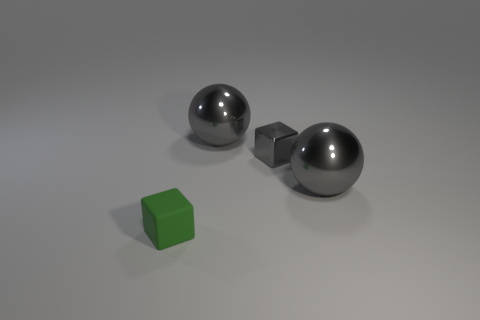Is there any other thing that is made of the same material as the small green object?
Offer a terse response. No. How many other things are the same shape as the small shiny object?
Keep it short and to the point. 1. There is a small thing behind the small matte thing; what shape is it?
Offer a terse response. Cube. The rubber block is what color?
Ensure brevity in your answer.  Green. What number of other things are the same size as the metallic cube?
Your response must be concise. 1. The small green cube that is in front of the tiny thing that is behind the small green matte object is made of what material?
Make the answer very short. Rubber. Do the green thing and the cube that is behind the small matte cube have the same size?
Keep it short and to the point. Yes. Are there any small blocks that have the same color as the tiny metallic object?
Keep it short and to the point. No. How many large things are rubber cubes or gray cubes?
Your answer should be compact. 0. What number of small rubber cubes are there?
Offer a very short reply. 1. 